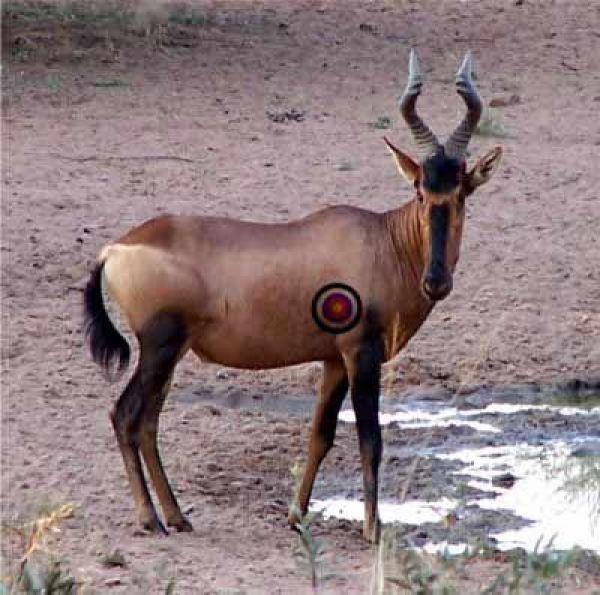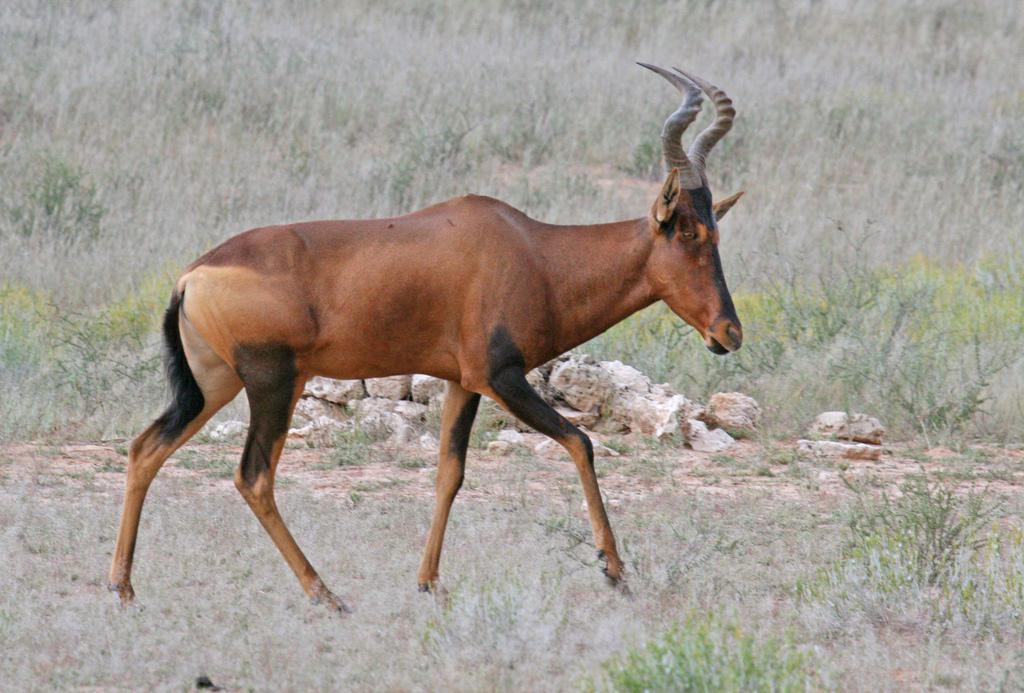The first image is the image on the left, the second image is the image on the right. For the images shown, is this caption "There are two antelopes in the image pair, both facing right." true? Answer yes or no. Yes. The first image is the image on the left, the second image is the image on the right. Given the left and right images, does the statement "One hooved animal has its body turned rightward and head facing forward, and the other stands with head and body in profile." hold true? Answer yes or no. Yes. 